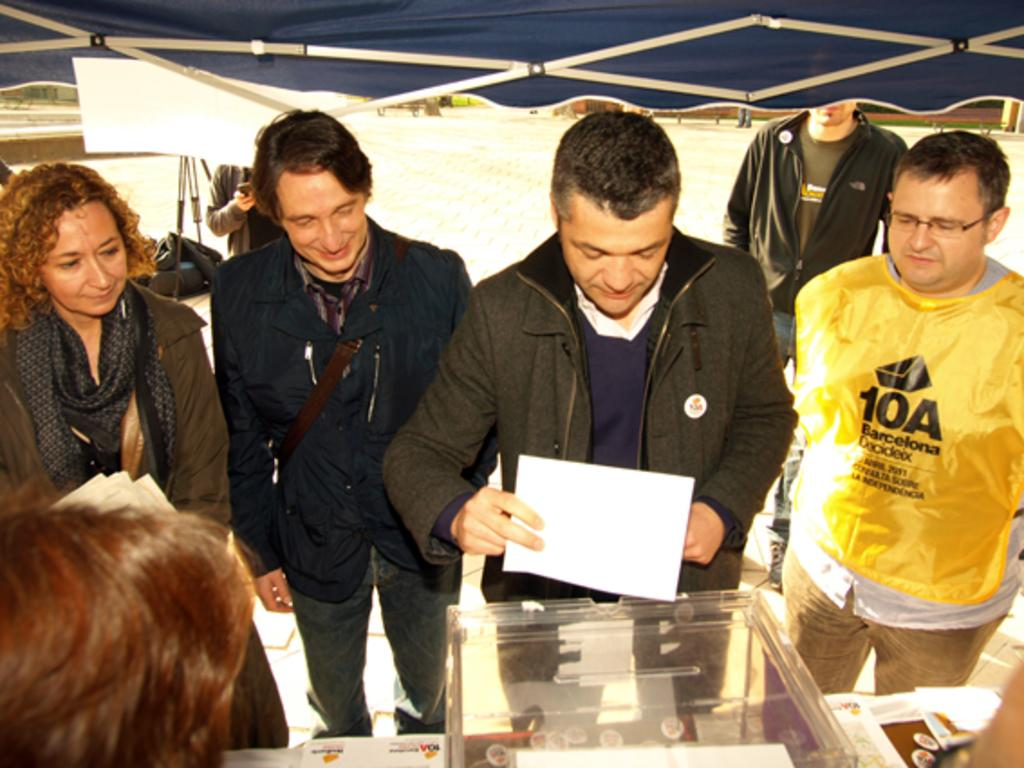What is on the table in the image? There are objects on the table in the image. Can you describe the people in the image? There are people in the image. What structure is visible at the top of the image? There is a tent visible at the top of the image. What type of pleasure can be seen being enjoyed by the people in the image? There is no indication of pleasure being enjoyed by the people in the image, as the provided facts do not mention any specific activities or emotions. How many times has the tent been folded in the image? The tent is visible in the image, but there is no information about it being folded or unfolded. 